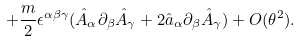<formula> <loc_0><loc_0><loc_500><loc_500>+ \frac { m } { 2 } \epsilon ^ { \alpha \beta \gamma } ( \hat { A } _ { \alpha } \partial _ { \beta } \hat { A } _ { \gamma } + 2 \hat { a } _ { \alpha } \partial _ { \beta } \hat { A } _ { \gamma } ) + O ( \theta ^ { 2 } ) .</formula> 